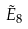Convert formula to latex. <formula><loc_0><loc_0><loc_500><loc_500>\tilde { E } _ { 8 }</formula> 